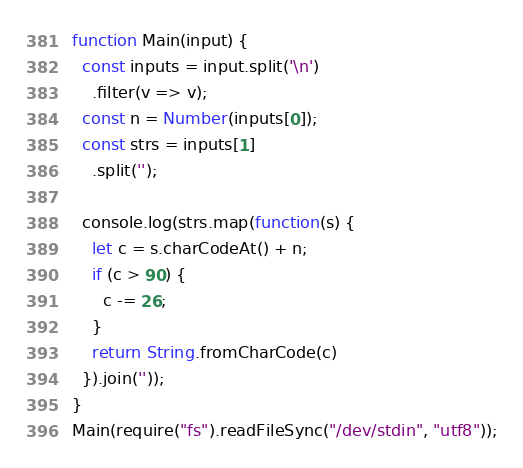Convert code to text. <code><loc_0><loc_0><loc_500><loc_500><_JavaScript_>function Main(input) {
  const inputs = input.split('\n')
    .filter(v => v);
  const n = Number(inputs[0]);
  const strs = inputs[1]
    .split('');
  
  console.log(strs.map(function(s) {
    let c = s.charCodeAt() + n;
    if (c > 90) {
      c -= 26;
    }
    return String.fromCharCode(c)
  }).join(''));
}
Main(require("fs").readFileSync("/dev/stdin", "utf8"));</code> 